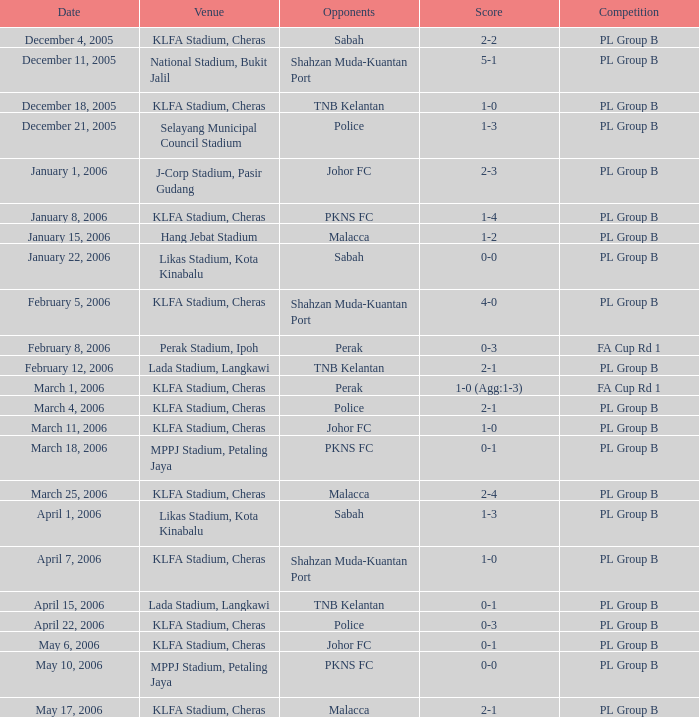Which Competition has a Score of 0-1, and Opponents of pkns fc? PL Group B. Write the full table. {'header': ['Date', 'Venue', 'Opponents', 'Score', 'Competition'], 'rows': [['December 4, 2005', 'KLFA Stadium, Cheras', 'Sabah', '2-2', 'PL Group B'], ['December 11, 2005', 'National Stadium, Bukit Jalil', 'Shahzan Muda-Kuantan Port', '5-1', 'PL Group B'], ['December 18, 2005', 'KLFA Stadium, Cheras', 'TNB Kelantan', '1-0', 'PL Group B'], ['December 21, 2005', 'Selayang Municipal Council Stadium', 'Police', '1-3', 'PL Group B'], ['January 1, 2006', 'J-Corp Stadium, Pasir Gudang', 'Johor FC', '2-3', 'PL Group B'], ['January 8, 2006', 'KLFA Stadium, Cheras', 'PKNS FC', '1-4', 'PL Group B'], ['January 15, 2006', 'Hang Jebat Stadium', 'Malacca', '1-2', 'PL Group B'], ['January 22, 2006', 'Likas Stadium, Kota Kinabalu', 'Sabah', '0-0', 'PL Group B'], ['February 5, 2006', 'KLFA Stadium, Cheras', 'Shahzan Muda-Kuantan Port', '4-0', 'PL Group B'], ['February 8, 2006', 'Perak Stadium, Ipoh', 'Perak', '0-3', 'FA Cup Rd 1'], ['February 12, 2006', 'Lada Stadium, Langkawi', 'TNB Kelantan', '2-1', 'PL Group B'], ['March 1, 2006', 'KLFA Stadium, Cheras', 'Perak', '1-0 (Agg:1-3)', 'FA Cup Rd 1'], ['March 4, 2006', 'KLFA Stadium, Cheras', 'Police', '2-1', 'PL Group B'], ['March 11, 2006', 'KLFA Stadium, Cheras', 'Johor FC', '1-0', 'PL Group B'], ['March 18, 2006', 'MPPJ Stadium, Petaling Jaya', 'PKNS FC', '0-1', 'PL Group B'], ['March 25, 2006', 'KLFA Stadium, Cheras', 'Malacca', '2-4', 'PL Group B'], ['April 1, 2006', 'Likas Stadium, Kota Kinabalu', 'Sabah', '1-3', 'PL Group B'], ['April 7, 2006', 'KLFA Stadium, Cheras', 'Shahzan Muda-Kuantan Port', '1-0', 'PL Group B'], ['April 15, 2006', 'Lada Stadium, Langkawi', 'TNB Kelantan', '0-1', 'PL Group B'], ['April 22, 2006', 'KLFA Stadium, Cheras', 'Police', '0-3', 'PL Group B'], ['May 6, 2006', 'KLFA Stadium, Cheras', 'Johor FC', '0-1', 'PL Group B'], ['May 10, 2006', 'MPPJ Stadium, Petaling Jaya', 'PKNS FC', '0-0', 'PL Group B'], ['May 17, 2006', 'KLFA Stadium, Cheras', 'Malacca', '2-1', 'PL Group B']]} 